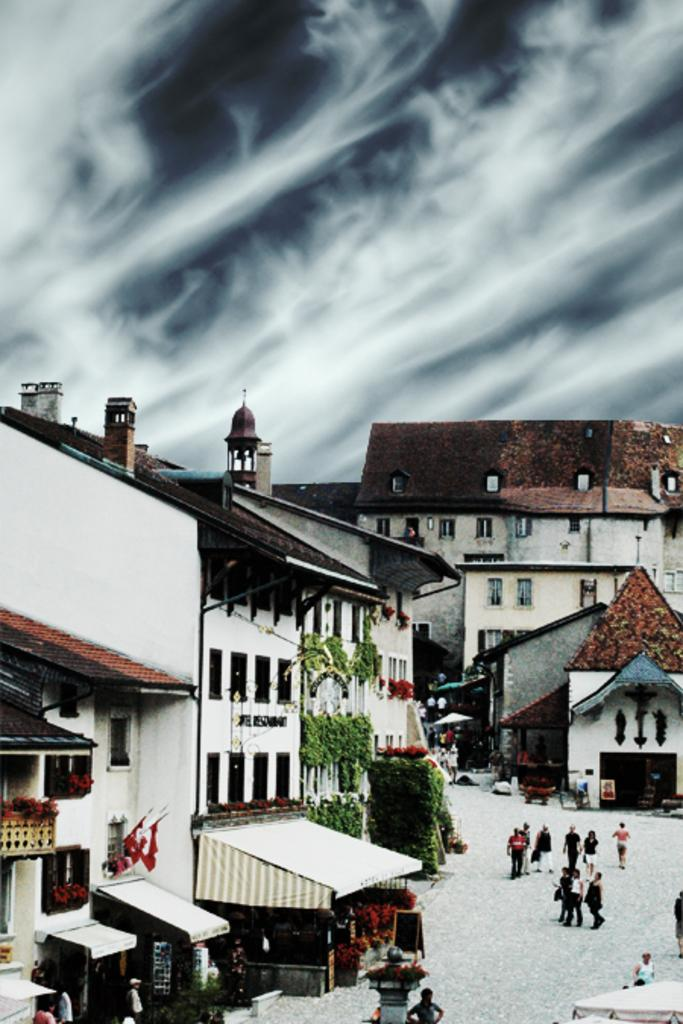What are the people in the image doing? The people in the image are walking on the road. Where are the people located in the image? The people are on the right side of the image. What can be seen in the background of the image? There are homes visible in the background. What is visible in the sky in the image? The sky is visible in the image, and clouds are present. What type of servant can be seen in the image? There is no servant present in the image. What is the aftermath of the event depicted in the image? There is no event depicted in the image, so there is no aftermath to discuss. 